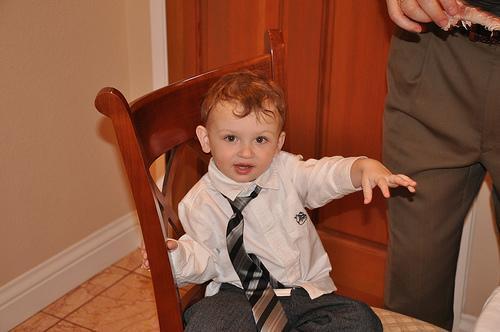How many people can be seen in the picture?
Give a very brief answer. 2. 